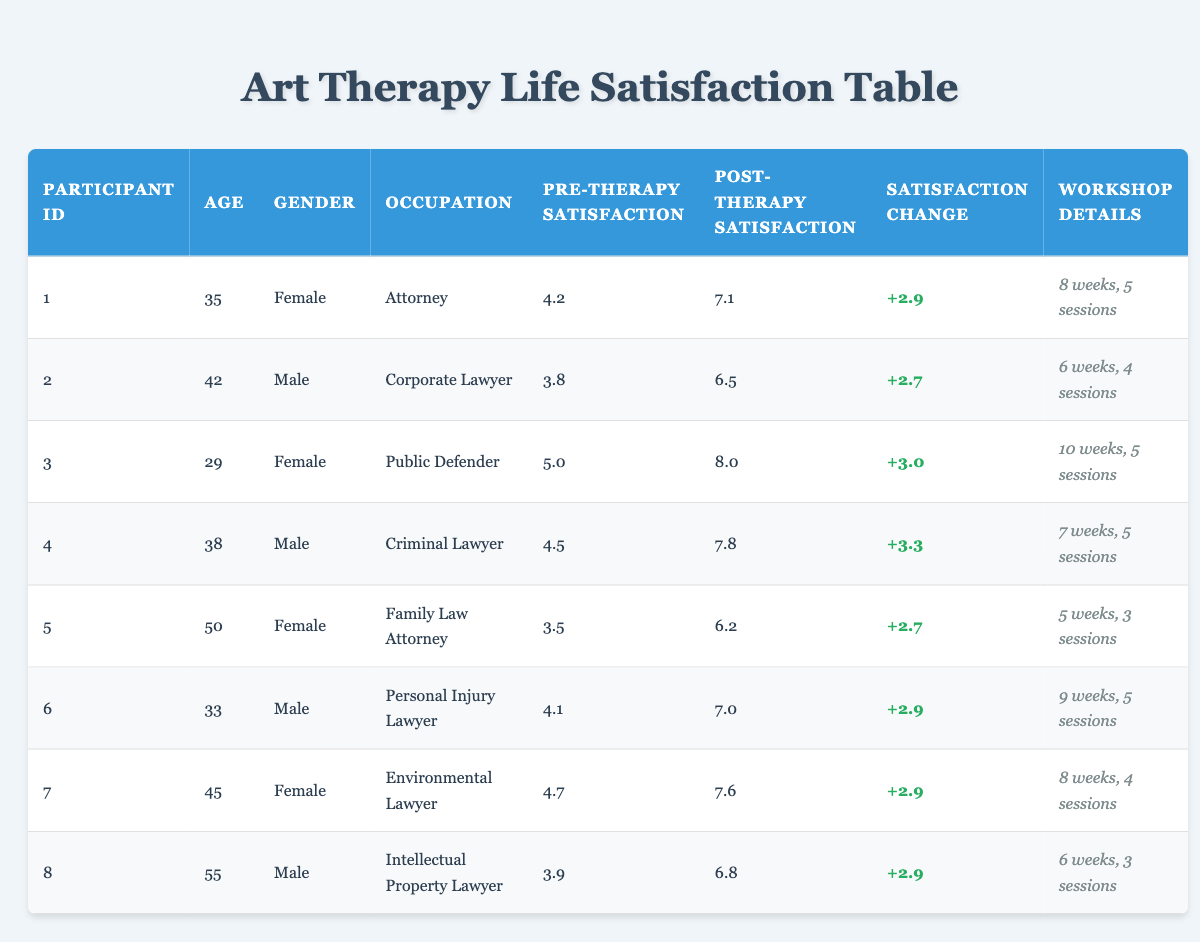What is the pre-art therapy satisfaction rating for participant ID 3? The pre-art therapy satisfaction rating for participant ID 3 is listed in the table under the corresponding column. It shows a value of 5.0.
Answer: 5.0 What is the post-art therapy satisfaction rating for the oldest participant? The oldest participant is participant ID 8, aged 55, and their post-art therapy satisfaction rating is found in the corresponding column, which shows a value of 6.8.
Answer: 6.8 How many participants have a satisfaction change greater than 3.0? By reviewing the satisfaction change column, we can count how many participants have a change greater than 3.0. Participants ID 3 and 4 have changes of +3.0 and +3.3, respectively. Therefore, there are 2 participants.
Answer: 2 What is the average pre-art therapy satisfaction rating across all participants? To calculate the average pre-art therapy satisfaction rating, we sum all the pre-art therapy ratings: (4.2 + 3.8 + 5.0 + 4.5 + 3.5 + 4.1 + 4.7 + 3.9) = 34.7. We divide this by the number of participants, which is 8, resulting in an average of 34.7/8 = 4.34.
Answer: 4.34 Is there any participant whose post-art therapy satisfaction rating decreased compared to their pre-art therapy satisfaction rating? Reviewing the post-art therapy and pre-art therapy satisfaction columns will show that all participants have increased their ratings after the therapy sessions. Therefore, the answer is no.
Answer: No What is the maximum satisfaction change recorded among all participants? By examining the satisfaction change column, we identify the largest value, which is +3.3 for participant ID 4.
Answer: +3.3 Which gender had the highest average post-art therapy satisfaction rating? Here, we calculate the post-art therapy satisfaction ratings for each gender. For females: (7.1 + 8.0 + 7.6) / 4 = 7.575. For males: (6.5 + 7.8 + 7.0 + 6.8) / 4 = 7.025. Females have a higher average satisfaction rating.
Answer: Females What was the workshop duration with the lowest average satisfaction change? To find the lowest average satisfaction change, we sum the satisfaction changes for each unique workshop duration and count the participants. For 5 weeks, the total change is 2.7; for 6 weeks, it's 2.7; for 7 weeks, it's 3.3; for 8 weeks, it's 2.9; and for 9 weeks, it's 2.9. Since 5 and 6 weeks both have the lowest total, we note that the average is the lowest for both.
Answer: 5 and 6 weeks How many male participants attended more than 4 sessions? Reviewing the sessions attended column for male participants (IDs 2, 4, 6, and 8), we see that participants ID 4 and 6 attended 5 sessions, while participant ID 2 attended 4. Only participant ID 8 attended 3 sessions. Thus, only 2 male participants attended more than 4 sessions.
Answer: 2 